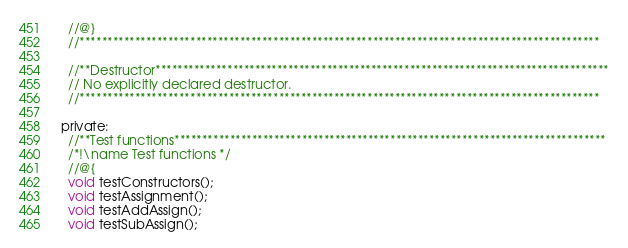Convert code to text. <code><loc_0><loc_0><loc_500><loc_500><_C_>   //@}
   //**********************************************************************************************

   //**Destructor**********************************************************************************
   // No explicitly declared destructor.
   //**********************************************************************************************

 private:
   //**Test functions******************************************************************************
   /*!\name Test functions */
   //@{
   void testConstructors();
   void testAssignment();
   void testAddAssign();
   void testSubAssign();</code> 